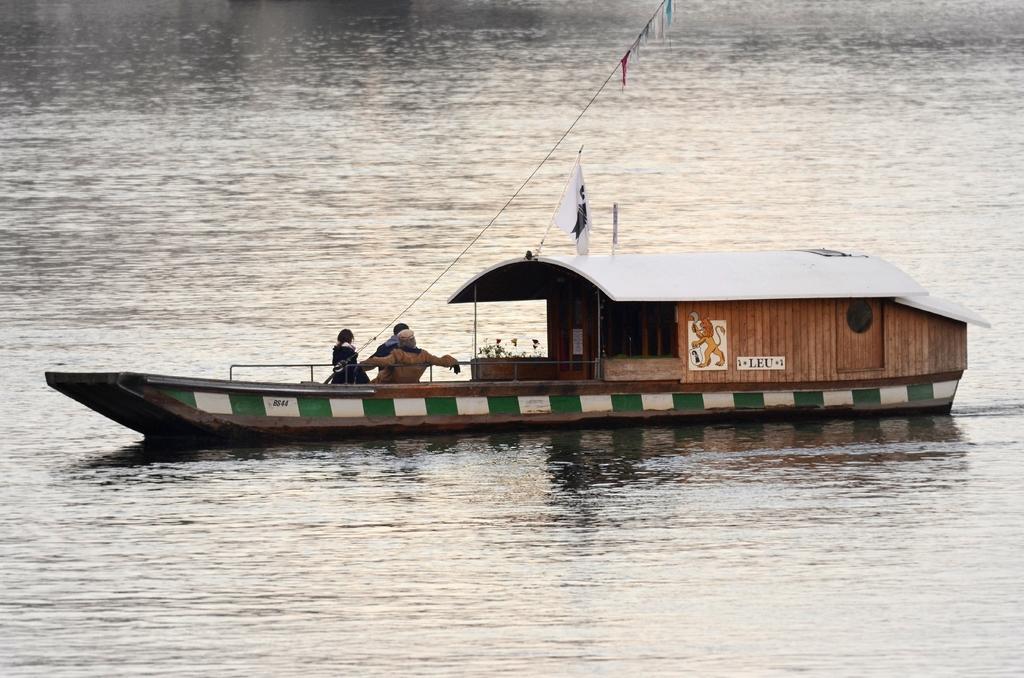Can you describe this image briefly? In the center of the image we can see boats on the river and there are people sitting in the boat. 